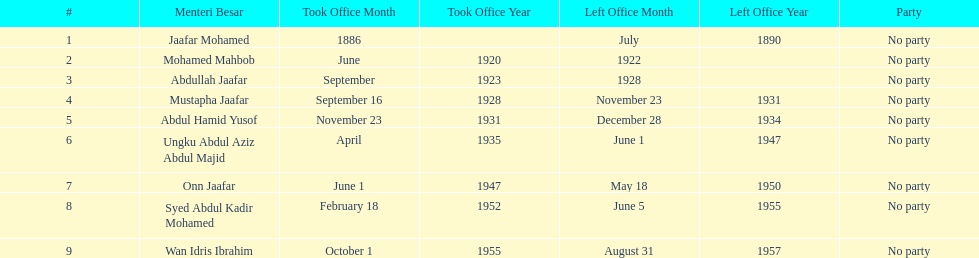How long did ungku abdul aziz abdul majid serve? 12 years. 